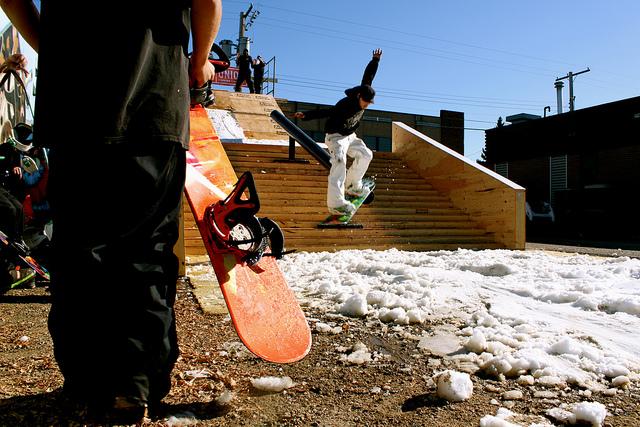Is the person planning to snowboard?
Write a very short answer. Yes. What color is the skateboard in the foreground?
Short answer required. Orange. Is there a lot of snow?
Write a very short answer. No. 